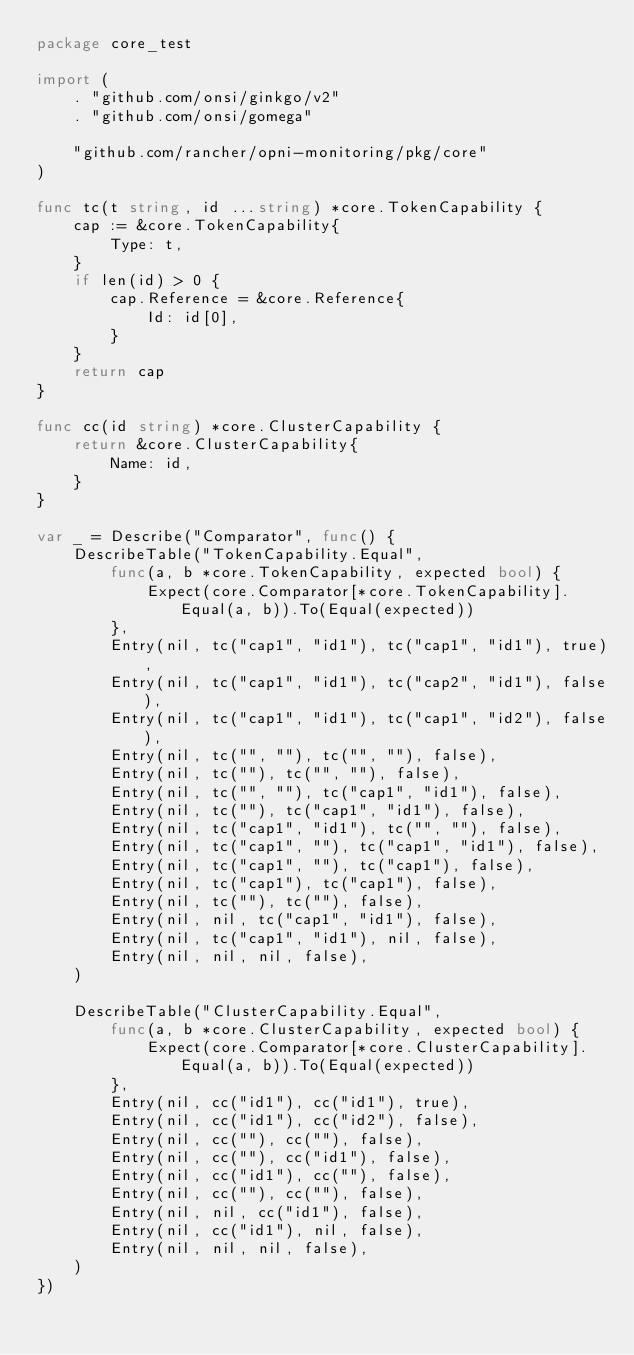<code> <loc_0><loc_0><loc_500><loc_500><_Go_>package core_test

import (
	. "github.com/onsi/ginkgo/v2"
	. "github.com/onsi/gomega"

	"github.com/rancher/opni-monitoring/pkg/core"
)

func tc(t string, id ...string) *core.TokenCapability {
	cap := &core.TokenCapability{
		Type: t,
	}
	if len(id) > 0 {
		cap.Reference = &core.Reference{
			Id: id[0],
		}
	}
	return cap
}

func cc(id string) *core.ClusterCapability {
	return &core.ClusterCapability{
		Name: id,
	}
}

var _ = Describe("Comparator", func() {
	DescribeTable("TokenCapability.Equal",
		func(a, b *core.TokenCapability, expected bool) {
			Expect(core.Comparator[*core.TokenCapability].Equal(a, b)).To(Equal(expected))
		},
		Entry(nil, tc("cap1", "id1"), tc("cap1", "id1"), true),
		Entry(nil, tc("cap1", "id1"), tc("cap2", "id1"), false),
		Entry(nil, tc("cap1", "id1"), tc("cap1", "id2"), false),
		Entry(nil, tc("", ""), tc("", ""), false),
		Entry(nil, tc(""), tc("", ""), false),
		Entry(nil, tc("", ""), tc("cap1", "id1"), false),
		Entry(nil, tc(""), tc("cap1", "id1"), false),
		Entry(nil, tc("cap1", "id1"), tc("", ""), false),
		Entry(nil, tc("cap1", ""), tc("cap1", "id1"), false),
		Entry(nil, tc("cap1", ""), tc("cap1"), false),
		Entry(nil, tc("cap1"), tc("cap1"), false),
		Entry(nil, tc(""), tc(""), false),
		Entry(nil, nil, tc("cap1", "id1"), false),
		Entry(nil, tc("cap1", "id1"), nil, false),
		Entry(nil, nil, nil, false),
	)

	DescribeTable("ClusterCapability.Equal",
		func(a, b *core.ClusterCapability, expected bool) {
			Expect(core.Comparator[*core.ClusterCapability].Equal(a, b)).To(Equal(expected))
		},
		Entry(nil, cc("id1"), cc("id1"), true),
		Entry(nil, cc("id1"), cc("id2"), false),
		Entry(nil, cc(""), cc(""), false),
		Entry(nil, cc(""), cc("id1"), false),
		Entry(nil, cc("id1"), cc(""), false),
		Entry(nil, cc(""), cc(""), false),
		Entry(nil, nil, cc("id1"), false),
		Entry(nil, cc("id1"), nil, false),
		Entry(nil, nil, nil, false),
	)
})
</code> 